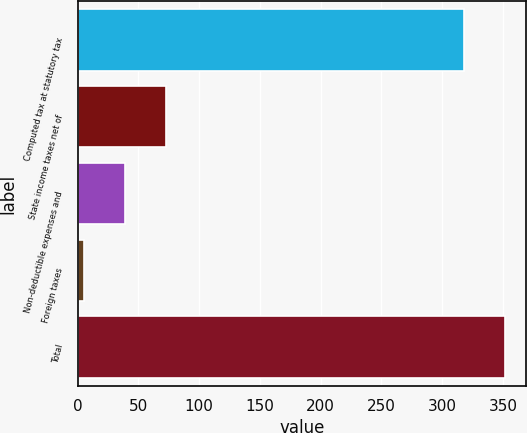Convert chart. <chart><loc_0><loc_0><loc_500><loc_500><bar_chart><fcel>Computed tax at statutory tax<fcel>State income taxes net of<fcel>Non-deductible expenses and<fcel>Foreign taxes<fcel>Total<nl><fcel>318<fcel>72.6<fcel>38.8<fcel>5<fcel>351.8<nl></chart> 